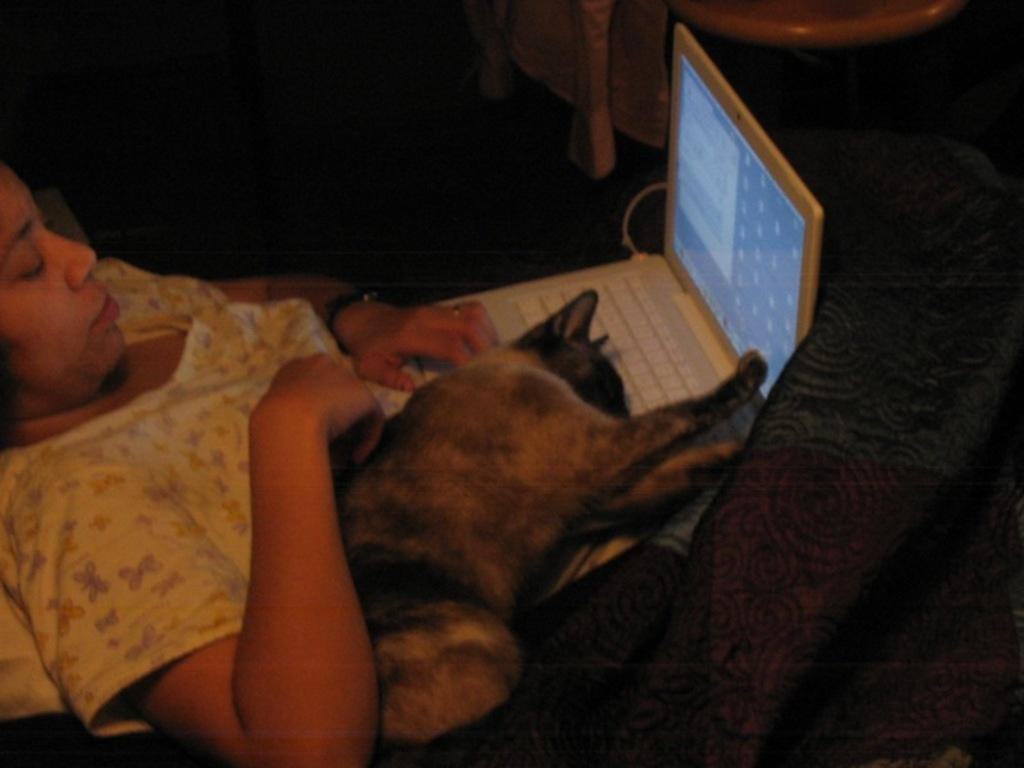What is the position of the person in the image? There is a person lying in the image. What electronic device is visible in the image? There is a laptop in the image. What type of animal is present in the image? There is a cat in the image. What is covering the person in the image? There is a blanket in the image. How many hens are present in the image? There are no hens present in the image. What type of planet is visible in the image? There is no planet visible in the image. 